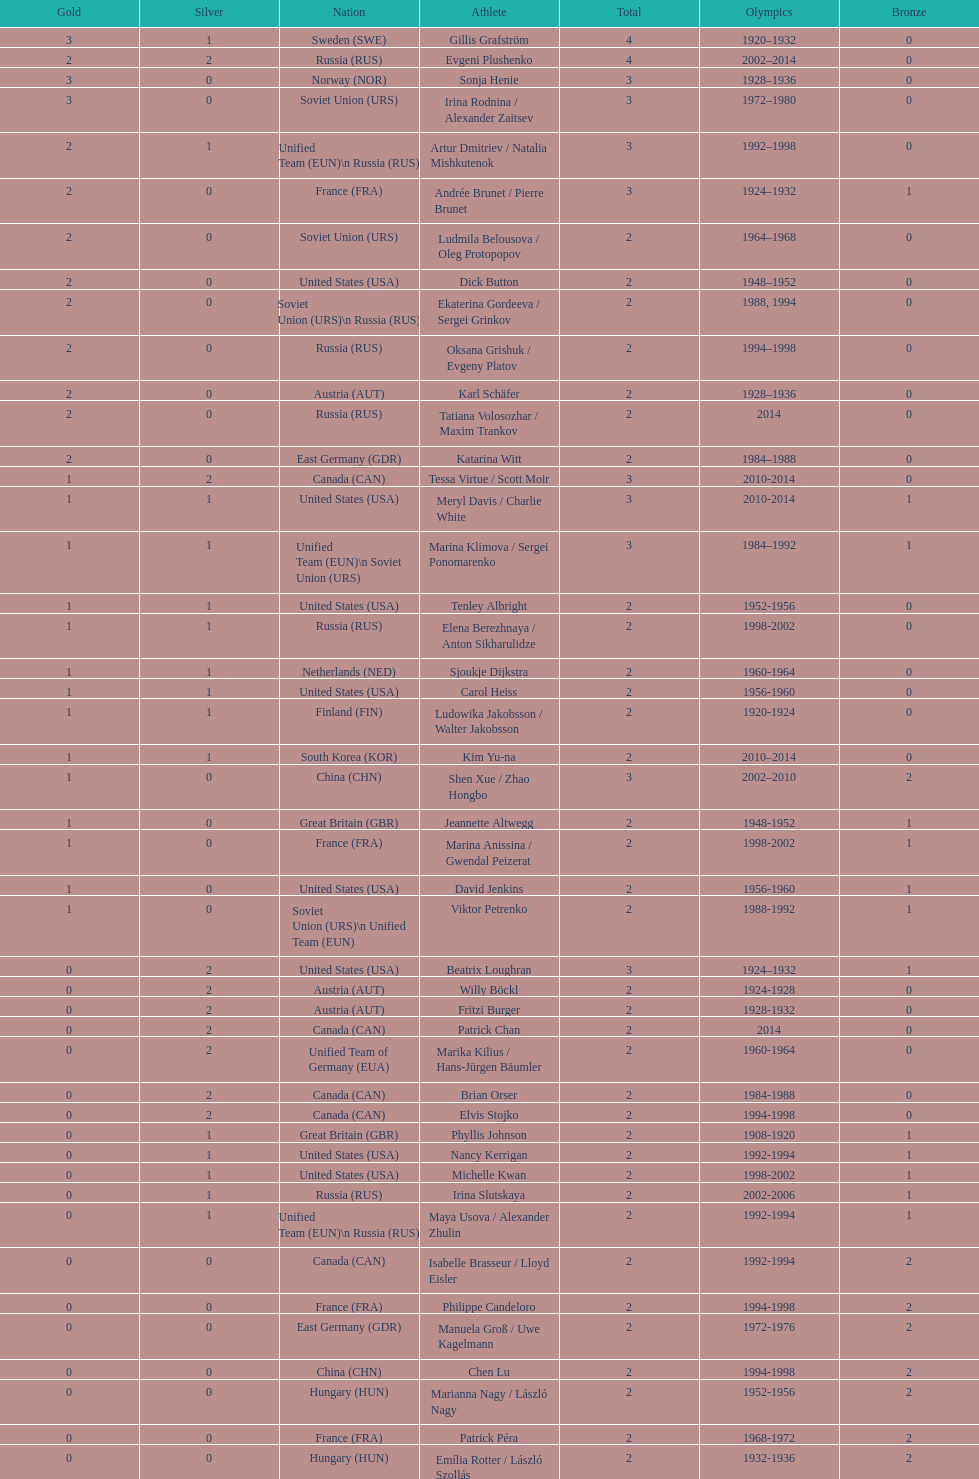How many silver medals did evgeni plushenko get? 2. 